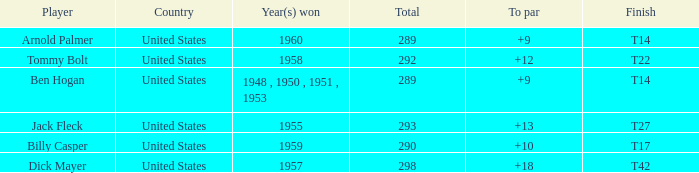What is Player, when Total is 292? Tommy Bolt. 